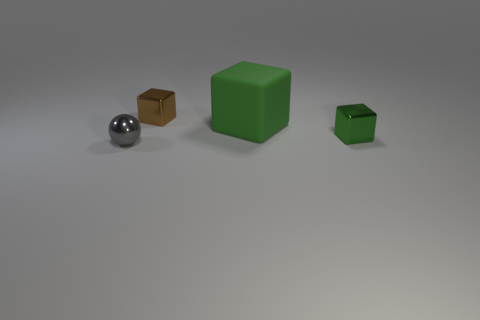Subtract all purple balls. How many green cubes are left? 2 Subtract all green shiny blocks. How many blocks are left? 2 Add 2 large gray rubber cylinders. How many objects exist? 6 Subtract all cubes. How many objects are left? 1 Add 2 large green things. How many large green things are left? 3 Add 4 large metallic objects. How many large metallic objects exist? 4 Subtract 1 brown cubes. How many objects are left? 3 Subtract all metal cubes. Subtract all small gray objects. How many objects are left? 1 